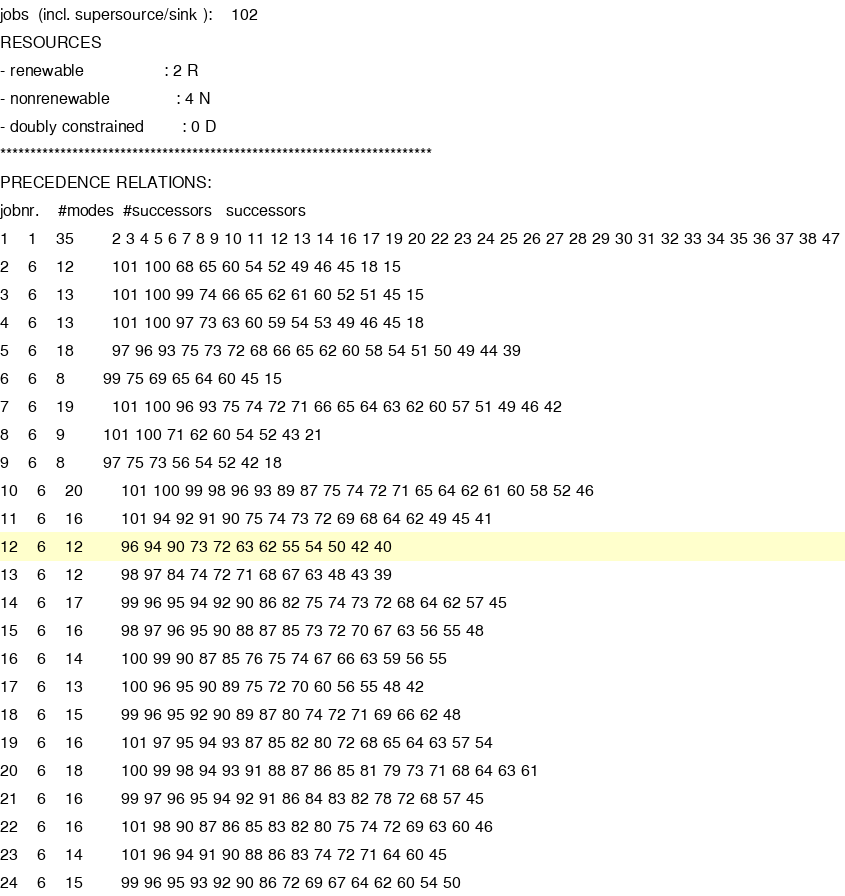Convert code to text. <code><loc_0><loc_0><loc_500><loc_500><_ObjectiveC_>jobs  (incl. supersource/sink ):	102
RESOURCES
- renewable                 : 2 R
- nonrenewable              : 4 N
- doubly constrained        : 0 D
************************************************************************
PRECEDENCE RELATIONS:
jobnr.    #modes  #successors   successors
1	1	35		2 3 4 5 6 7 8 9 10 11 12 13 14 16 17 19 20 22 23 24 25 26 27 28 29 30 31 32 33 34 35 36 37 38 47 
2	6	12		101 100 68 65 60 54 52 49 46 45 18 15 
3	6	13		101 100 99 74 66 65 62 61 60 52 51 45 15 
4	6	13		101 100 97 73 63 60 59 54 53 49 46 45 18 
5	6	18		97 96 93 75 73 72 68 66 65 62 60 58 54 51 50 49 44 39 
6	6	8		99 75 69 65 64 60 45 15 
7	6	19		101 100 96 93 75 74 72 71 66 65 64 63 62 60 57 51 49 46 42 
8	6	9		101 100 71 62 60 54 52 43 21 
9	6	8		97 75 73 56 54 52 42 18 
10	6	20		101 100 99 98 96 93 89 87 75 74 72 71 65 64 62 61 60 58 52 46 
11	6	16		101 94 92 91 90 75 74 73 72 69 68 64 62 49 45 41 
12	6	12		96 94 90 73 72 63 62 55 54 50 42 40 
13	6	12		98 97 84 74 72 71 68 67 63 48 43 39 
14	6	17		99 96 95 94 92 90 86 82 75 74 73 72 68 64 62 57 45 
15	6	16		98 97 96 95 90 88 87 85 73 72 70 67 63 56 55 48 
16	6	14		100 99 90 87 85 76 75 74 67 66 63 59 56 55 
17	6	13		100 96 95 90 89 75 72 70 60 56 55 48 42 
18	6	15		99 96 95 92 90 89 87 80 74 72 71 69 66 62 48 
19	6	16		101 97 95 94 93 87 85 82 80 72 68 65 64 63 57 54 
20	6	18		100 99 98 94 93 91 88 87 86 85 81 79 73 71 68 64 63 61 
21	6	16		99 97 96 95 94 92 91 86 84 83 82 78 72 68 57 45 
22	6	16		101 98 90 87 86 85 83 82 80 75 74 72 69 63 60 46 
23	6	14		101 96 94 91 90 88 86 83 74 72 71 64 60 45 
24	6	15		99 96 95 93 92 90 86 72 69 67 64 62 60 54 50 </code> 